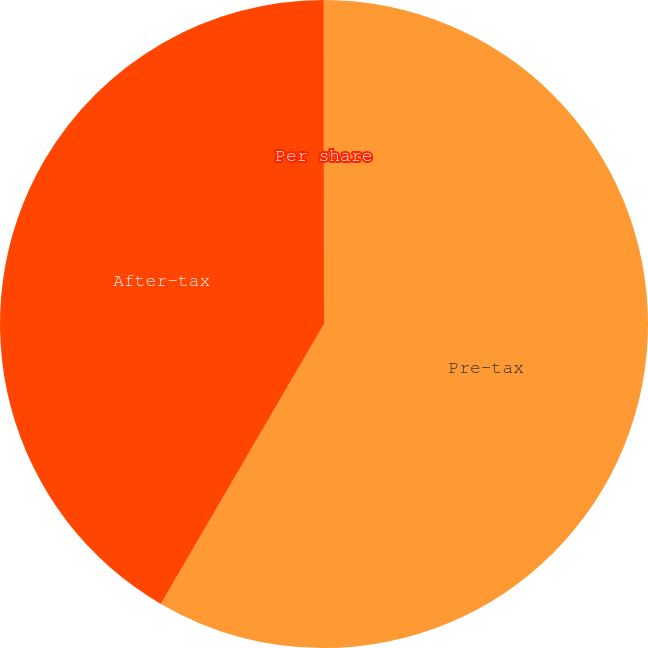Convert chart to OTSL. <chart><loc_0><loc_0><loc_500><loc_500><pie_chart><fcel>Pre-tax<fcel>After-tax<fcel>Per share<nl><fcel>58.4%<fcel>41.58%<fcel>0.02%<nl></chart> 